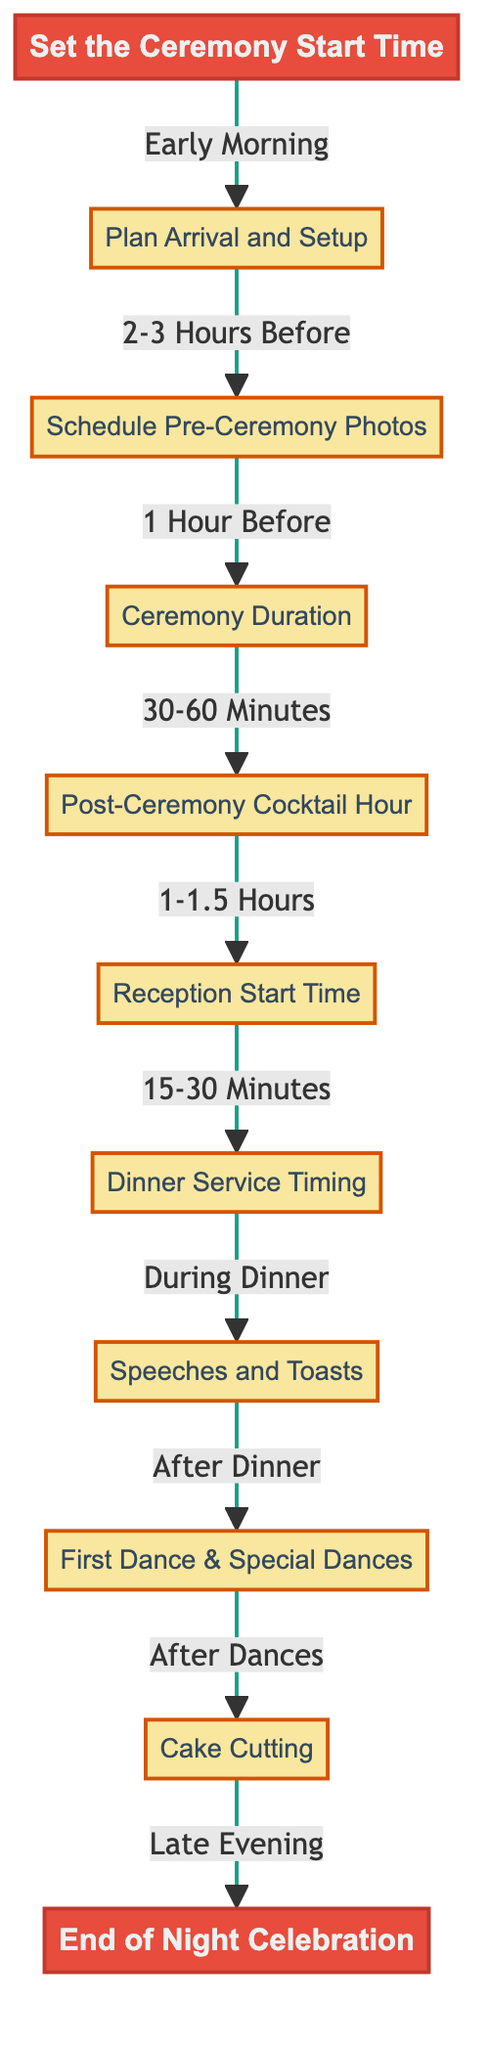What's the first step in the schedule? The diagram indicates that the first step is to "Set the Ceremony Start Time." This is clearly depicted at the top and connected to the beginning of the flowchart.
Answer: Set the Ceremony Start Time How long is the cocktail hour? According to the diagram, the cocktail hour is scheduled for "1-1.5 Hours," which is indicated following the "Post-Ceremony Cocktail Hour" node.
Answer: 1-1.5 Hours What is scheduled directly after the ceremony duration? The flowchart shows that the next step after "Ceremony Duration" is "Post-Ceremony Cocktail Hour," demonstrated by the downward connection from D to E.
Answer: Post-Ceremony Cocktail Hour What is the estimated duration of the ceremony? The diagram states that the "Ceremony Duration" is estimated to be "30-60 Minutes," as identified within that specific node.
Answer: 30-60 Minutes How many major events are scheduled before the reception? By analyzing the diagram, there are four major events leading up to the reception: "Plan Arrival and Setup," "Schedule Pre-Ceremony Photos," "Ceremony Duration," and "Post-Ceremony Cocktail Hour." This can be confirmed by counting the nodes that precede the "Reception Start Time."
Answer: 4 What comes before the first dance? The flowchart directly indicates that "Speeches and Toasts" precedes "First Dance & Special Dances," as shown in the connections from H to I.
Answer: Speeches and Toasts What determines the start time of the reception? The diagram clearly shows that the "Reception Start Time" is dependent on ensuring that guests have had "adequate time during cocktail hour," emphasizing the importance of guest experience.
Answer: Adequate time during cocktail hour How does the timeline flow from the cake cutting to the end of the night celebration? The flowchart illustrates that after "Cake Cutting," the next event is the "End of Night Celebration," indicating a direct sequential flow from one event to the other, which helps in planning the night.
Answer: End of Night Celebration 